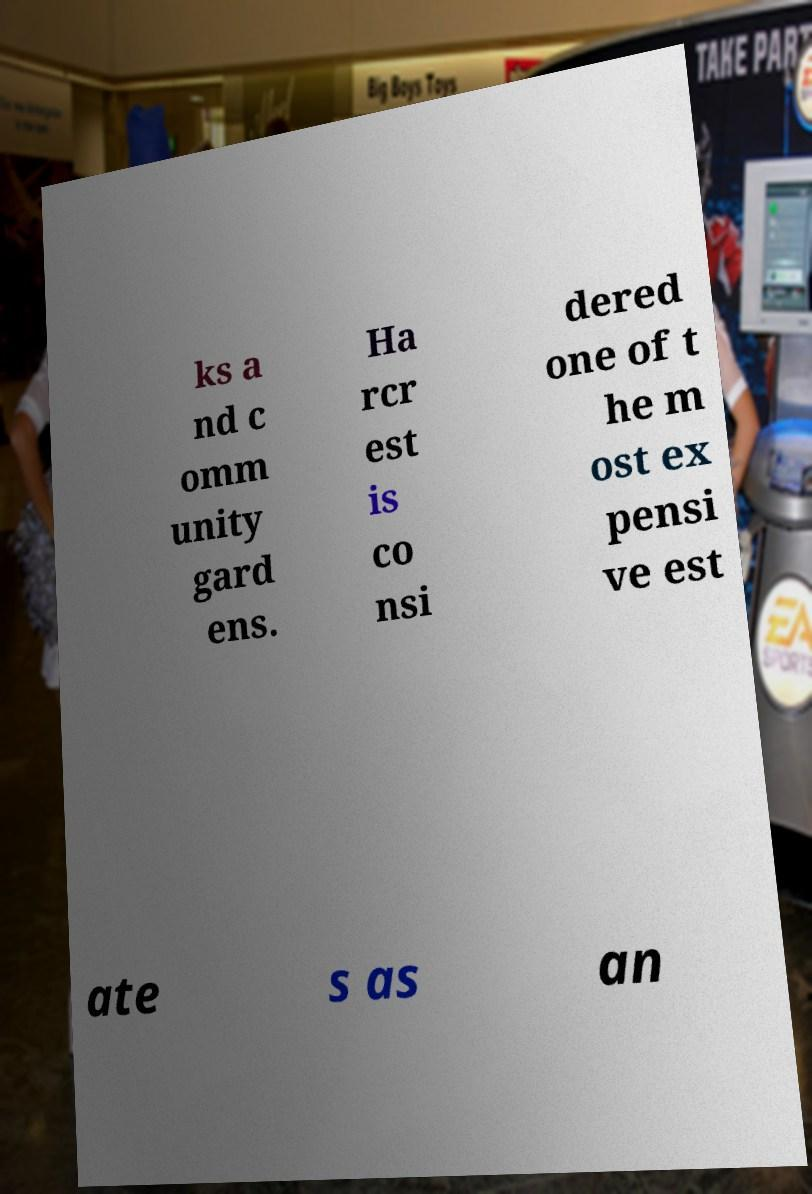I need the written content from this picture converted into text. Can you do that? ks a nd c omm unity gard ens. Ha rcr est is co nsi dered one of t he m ost ex pensi ve est ate s as an 